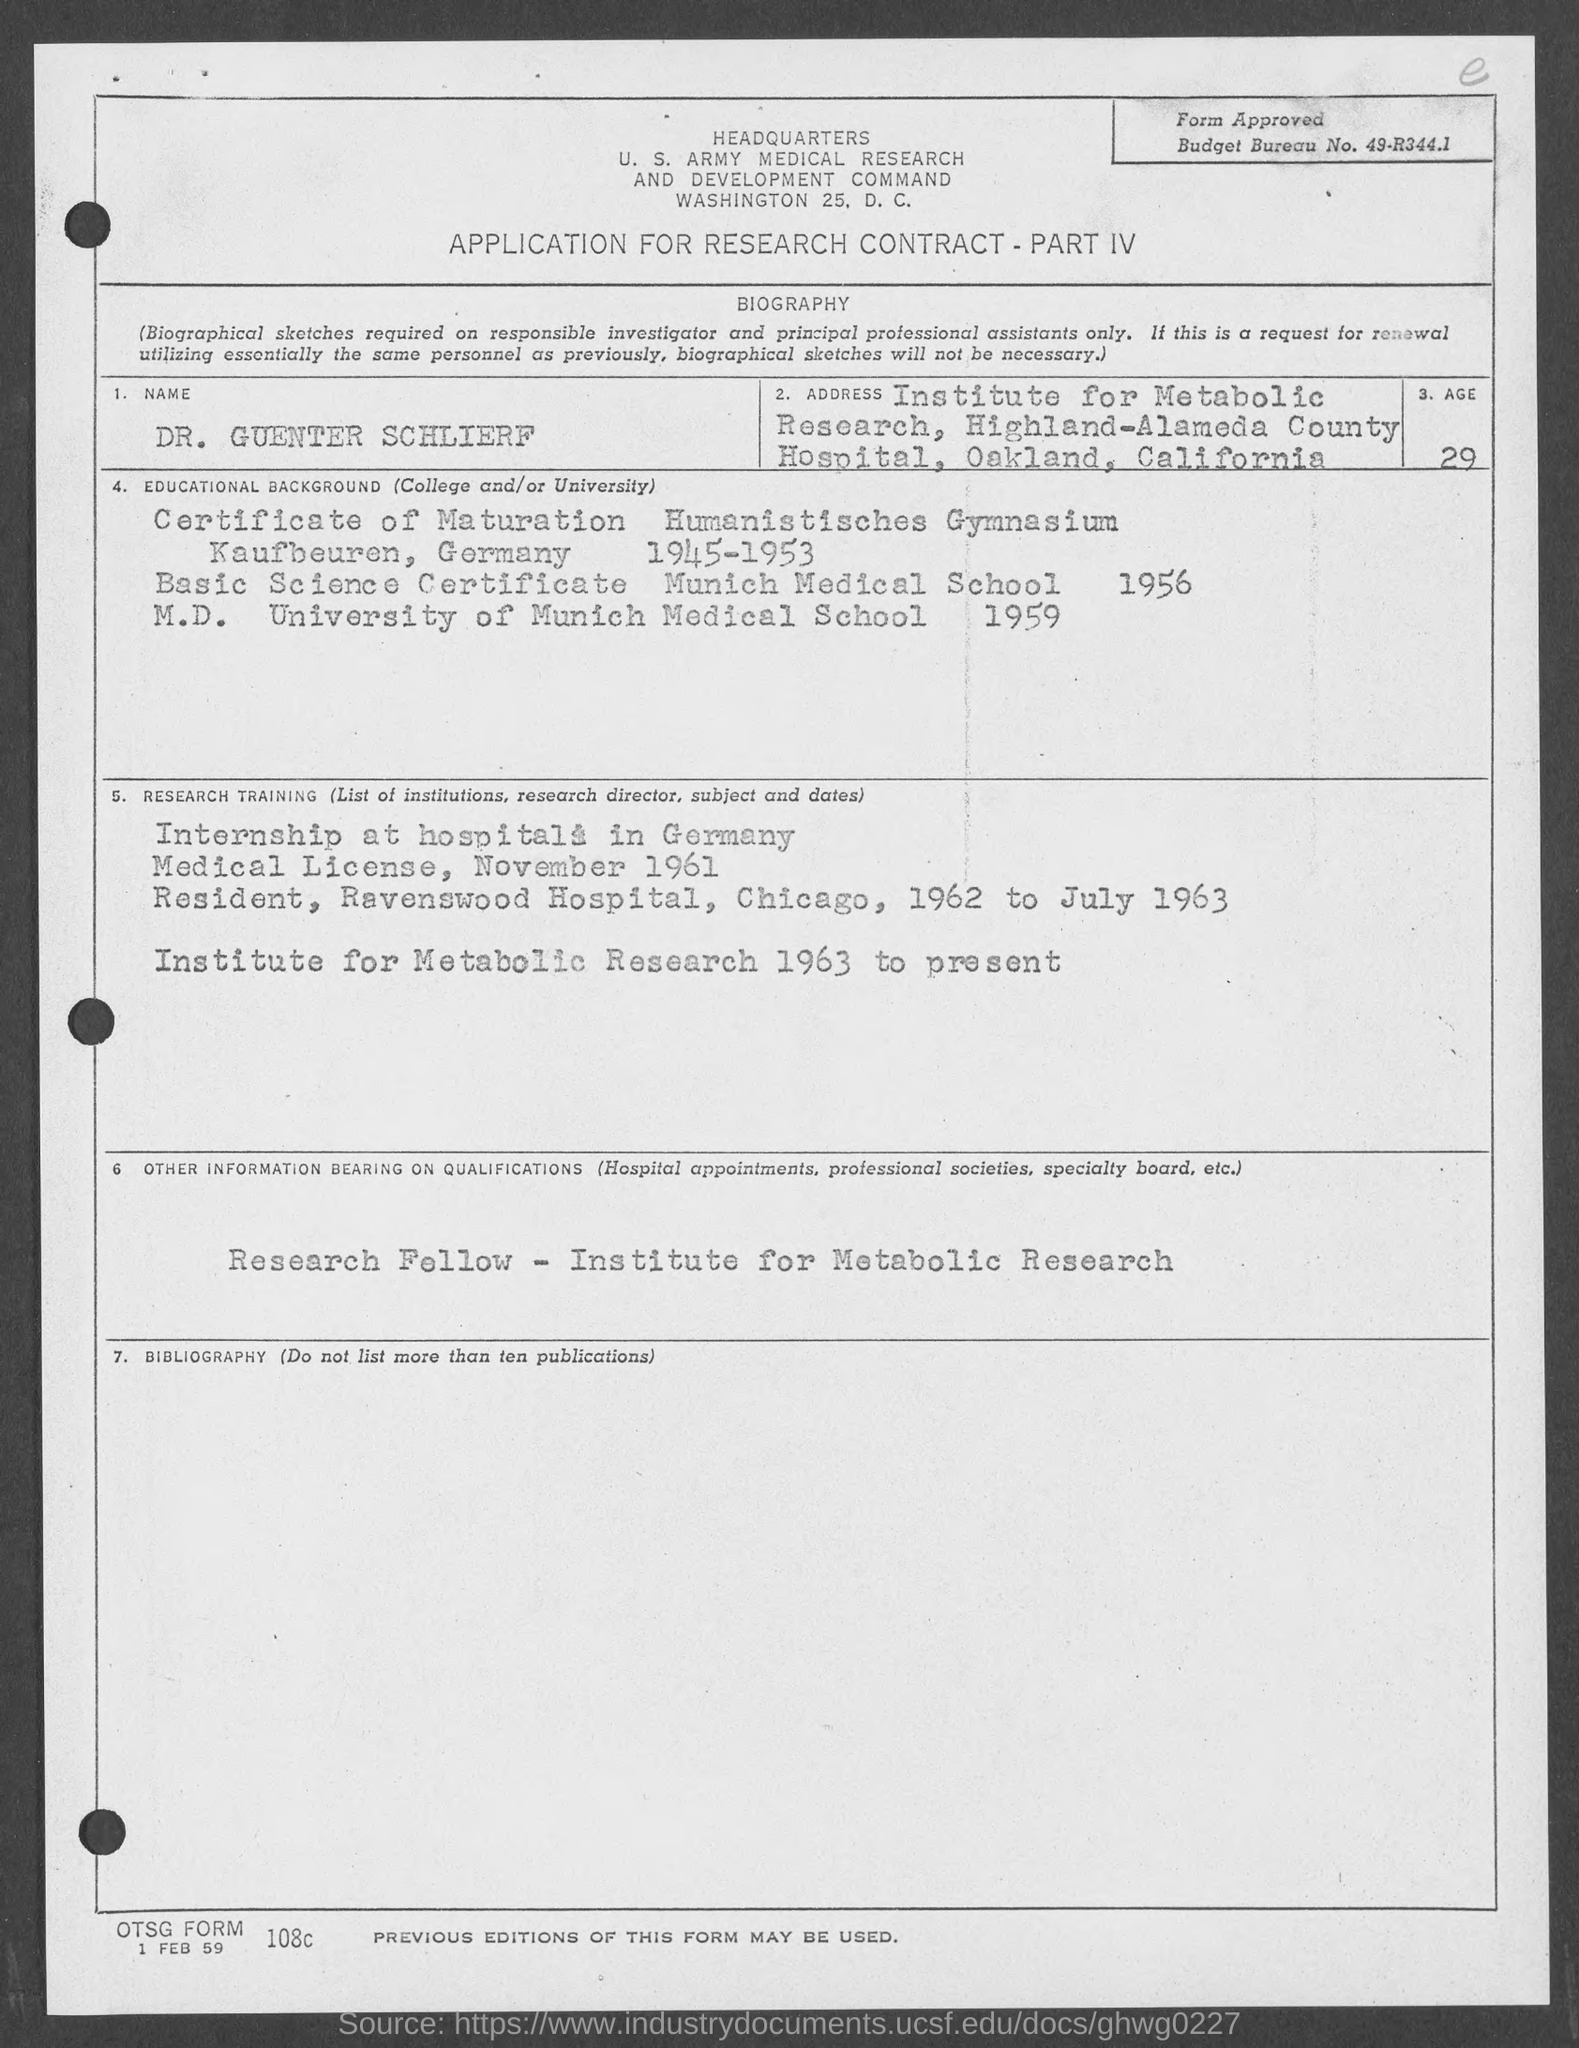Give some essential details in this illustration. The name of the person is Dr. Guenter Schlierf. In 1956, the candidate completed his basic Science certificate. The United States Army Medical Research and Development Command is located in Washington. The candidate completed his M.D. in the year 1959. The budget bureau number is 49-R344.1. 